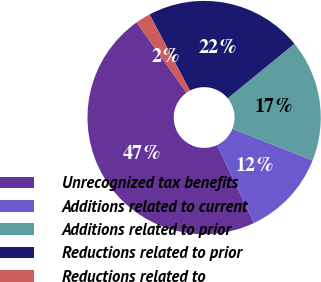<chart> <loc_0><loc_0><loc_500><loc_500><pie_chart><fcel>Unrecognized tax benefits<fcel>Additions related to current<fcel>Additions related to prior<fcel>Reductions related to prior<fcel>Reductions related to<nl><fcel>47.21%<fcel>11.96%<fcel>16.9%<fcel>21.84%<fcel>2.09%<nl></chart> 